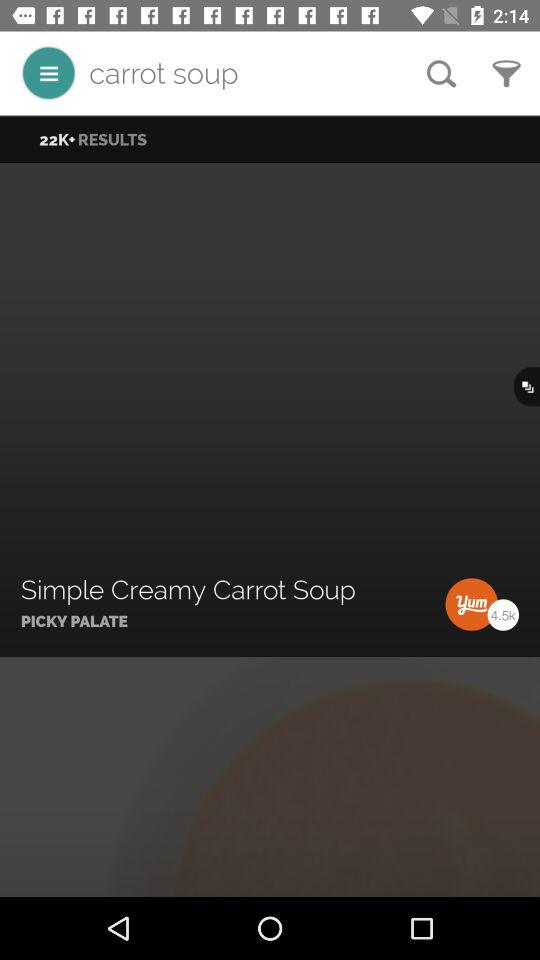How many pounds of carrots are required?
When the provided information is insufficient, respond with <no answer>. <no answer> 